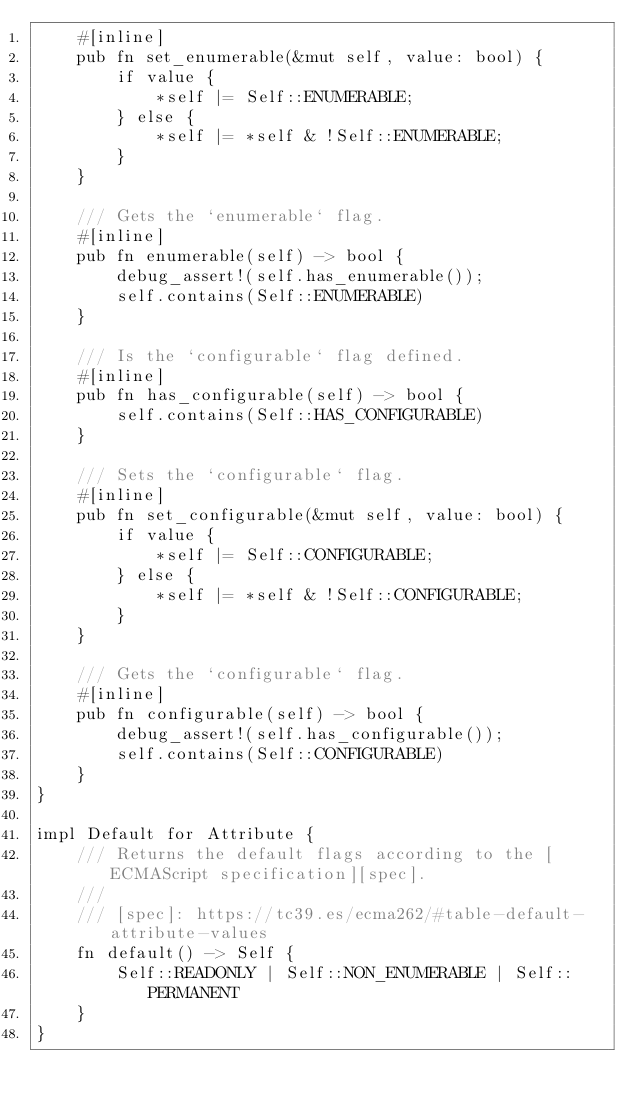Convert code to text. <code><loc_0><loc_0><loc_500><loc_500><_Rust_>    #[inline]
    pub fn set_enumerable(&mut self, value: bool) {
        if value {
            *self |= Self::ENUMERABLE;
        } else {
            *self |= *self & !Self::ENUMERABLE;
        }
    }

    /// Gets the `enumerable` flag.
    #[inline]
    pub fn enumerable(self) -> bool {
        debug_assert!(self.has_enumerable());
        self.contains(Self::ENUMERABLE)
    }

    /// Is the `configurable` flag defined.
    #[inline]
    pub fn has_configurable(self) -> bool {
        self.contains(Self::HAS_CONFIGURABLE)
    }

    /// Sets the `configurable` flag.
    #[inline]
    pub fn set_configurable(&mut self, value: bool) {
        if value {
            *self |= Self::CONFIGURABLE;
        } else {
            *self |= *self & !Self::CONFIGURABLE;
        }
    }

    /// Gets the `configurable` flag.
    #[inline]
    pub fn configurable(self) -> bool {
        debug_assert!(self.has_configurable());
        self.contains(Self::CONFIGURABLE)
    }
}

impl Default for Attribute {
    /// Returns the default flags according to the [ECMAScript specification][spec].
    ///
    /// [spec]: https://tc39.es/ecma262/#table-default-attribute-values
    fn default() -> Self {
        Self::READONLY | Self::NON_ENUMERABLE | Self::PERMANENT
    }
}
</code> 